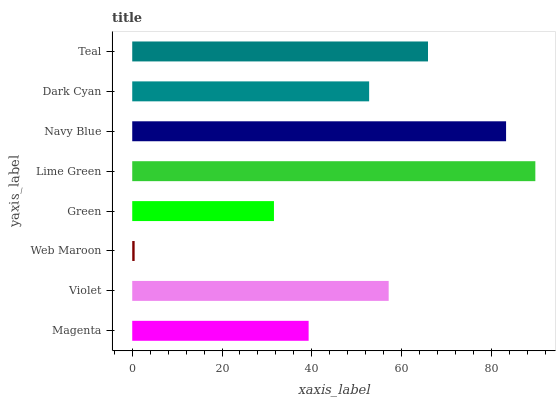Is Web Maroon the minimum?
Answer yes or no. Yes. Is Lime Green the maximum?
Answer yes or no. Yes. Is Violet the minimum?
Answer yes or no. No. Is Violet the maximum?
Answer yes or no. No. Is Violet greater than Magenta?
Answer yes or no. Yes. Is Magenta less than Violet?
Answer yes or no. Yes. Is Magenta greater than Violet?
Answer yes or no. No. Is Violet less than Magenta?
Answer yes or no. No. Is Violet the high median?
Answer yes or no. Yes. Is Dark Cyan the low median?
Answer yes or no. Yes. Is Dark Cyan the high median?
Answer yes or no. No. Is Magenta the low median?
Answer yes or no. No. 